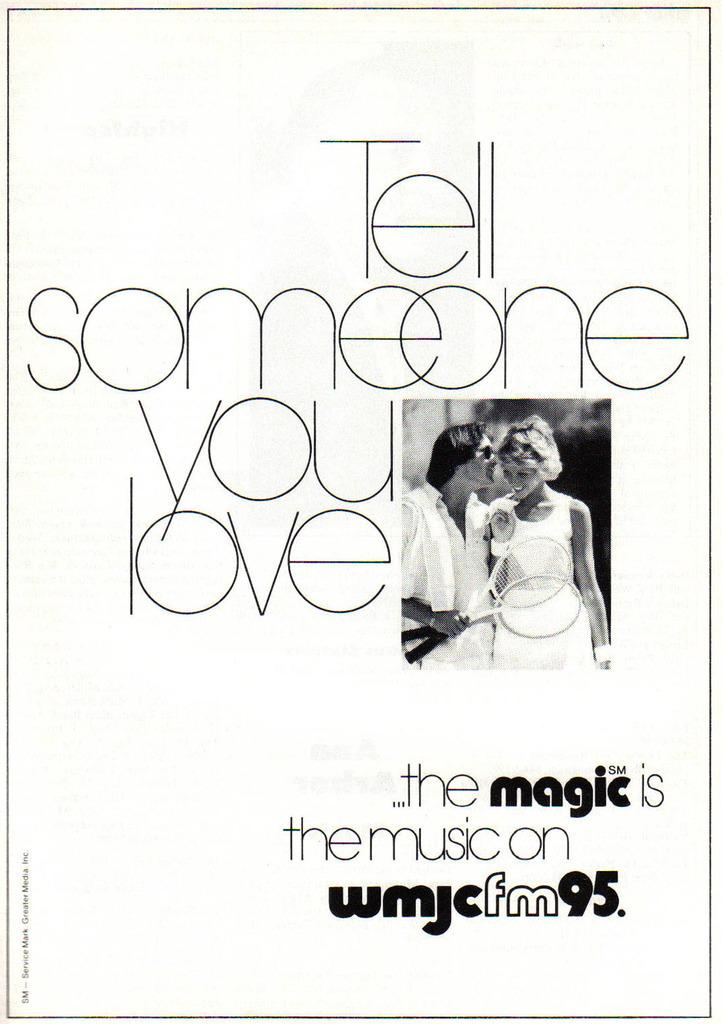What is featured on the poster in the image? There is a poster in the image, and it has an image of two persons. Can you describe the persons on the poster? One of the persons is a man holding two bats, and the other person is a woman standing beside the man. Is there any text on the poster? Yes, there is text on the poster. How many geese are flying in the image? There are no geese present in the image; it features a poster with an image of two persons. What type of paste is being used by the man in the image? There is no paste visible in the image; the man is holding two bats. 